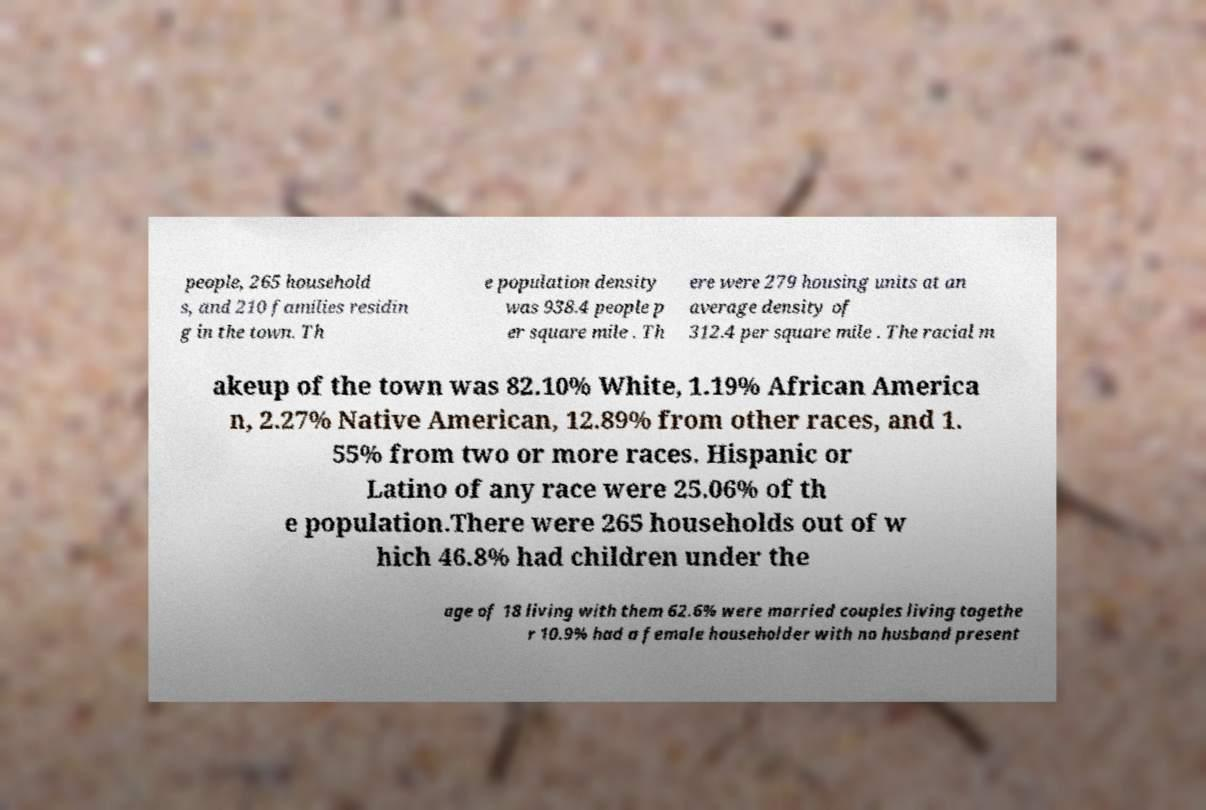For documentation purposes, I need the text within this image transcribed. Could you provide that? people, 265 household s, and 210 families residin g in the town. Th e population density was 938.4 people p er square mile . Th ere were 279 housing units at an average density of 312.4 per square mile . The racial m akeup of the town was 82.10% White, 1.19% African America n, 2.27% Native American, 12.89% from other races, and 1. 55% from two or more races. Hispanic or Latino of any race were 25.06% of th e population.There were 265 households out of w hich 46.8% had children under the age of 18 living with them 62.6% were married couples living togethe r 10.9% had a female householder with no husband present 